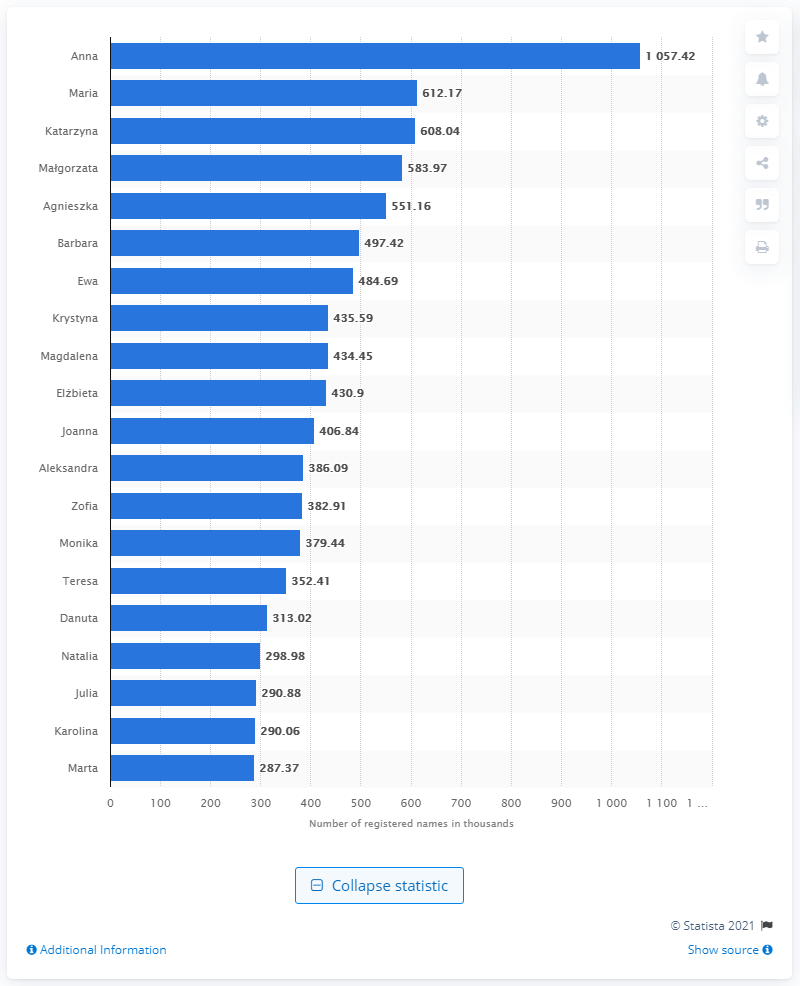Highlight a few significant elements in this photo. As of January 2021, the most popular female first name in Poland was Anna. 